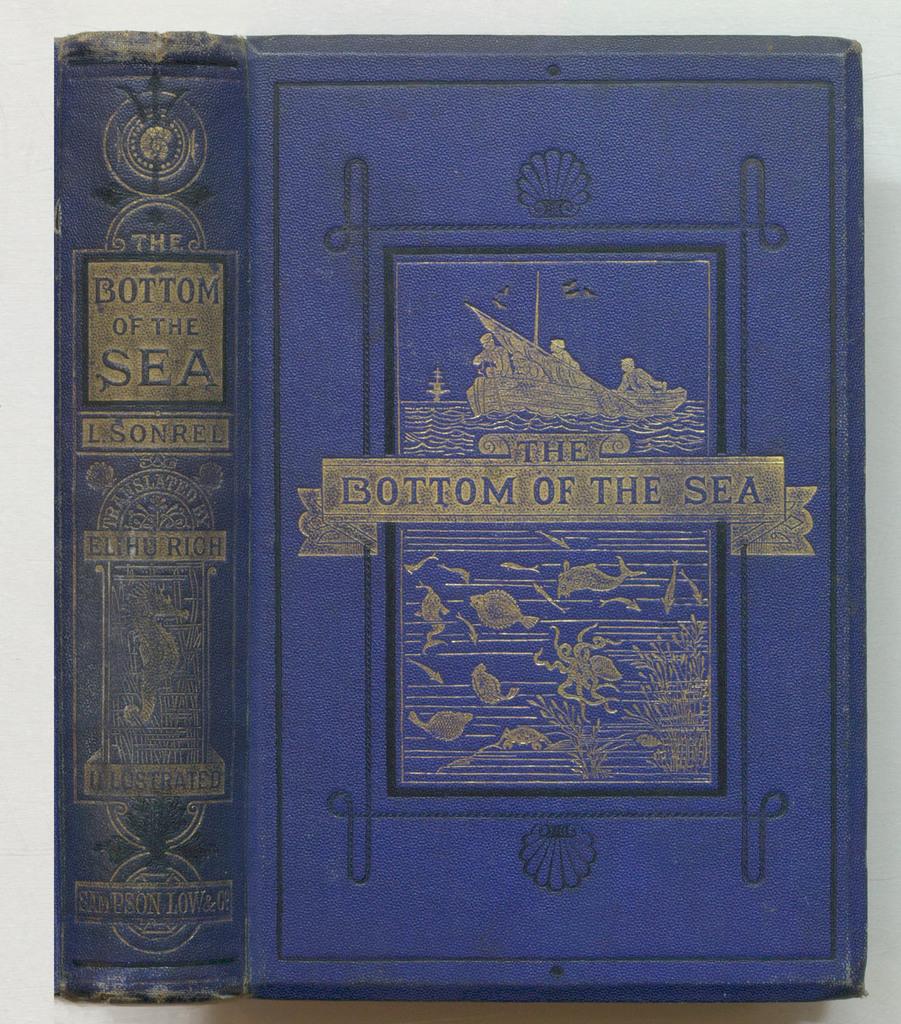Is this a book about the sea?
Make the answer very short. Yes. Who is the book translated by?
Provide a short and direct response. Unanswerable. 